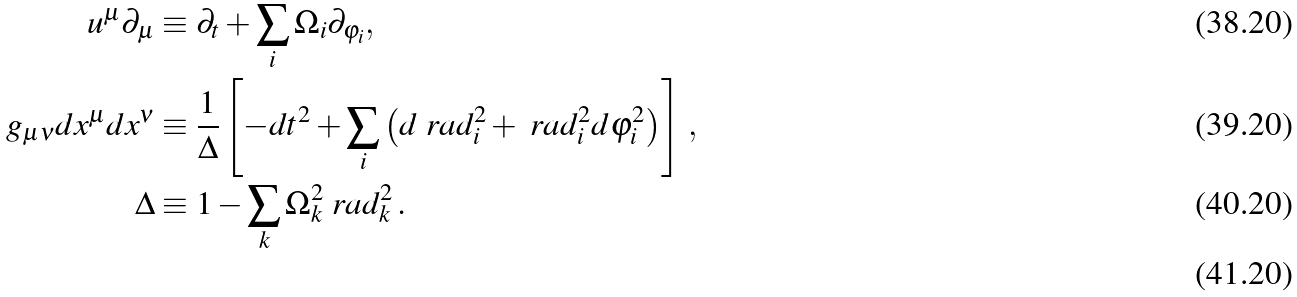<formula> <loc_0><loc_0><loc_500><loc_500>u ^ { \mu } \partial _ { \mu } & \equiv \partial _ { t } + \sum _ { i } \Omega _ { i } \partial _ { \varphi _ { i } } , \\ g _ { \mu \nu } d x ^ { \mu } d x ^ { \nu } & \equiv \frac { 1 } { \Delta } \left [ - d t ^ { 2 } + \sum _ { i } \left ( d \ r a d _ { i } ^ { 2 } + \ r a d _ { i } ^ { 2 } d \varphi _ { i } ^ { 2 } \right ) \right ] \, , \\ \Delta & \equiv 1 - \sum _ { k } \Omega _ { k } ^ { 2 } \ r a d _ { k } ^ { 2 } \, . \\</formula> 